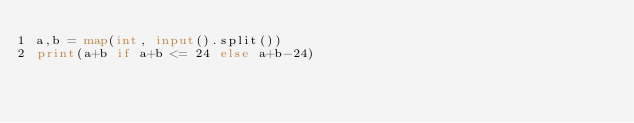<code> <loc_0><loc_0><loc_500><loc_500><_Python_>a,b = map(int, input().split())
print(a+b if a+b <= 24 else a+b-24)</code> 